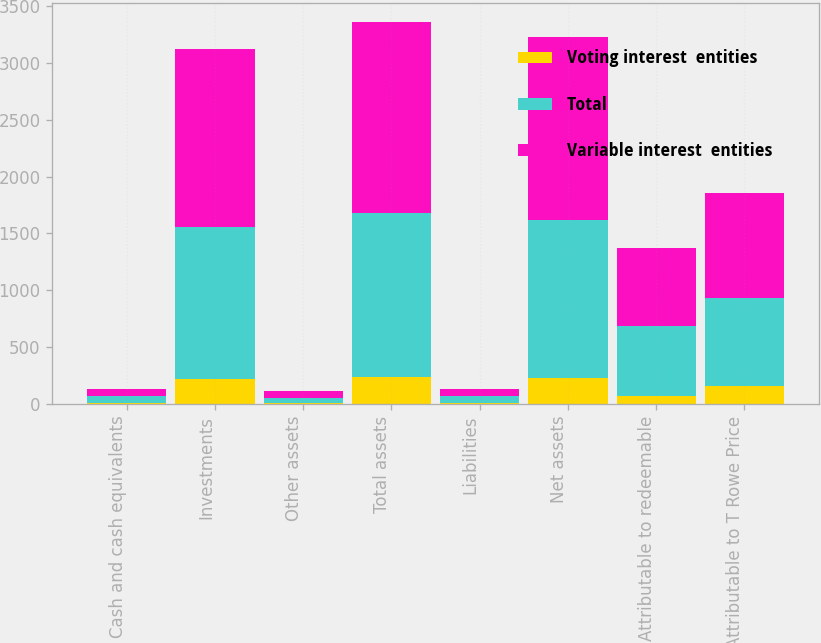Convert chart to OTSL. <chart><loc_0><loc_0><loc_500><loc_500><stacked_bar_chart><ecel><fcel>Cash and cash equivalents<fcel>Investments<fcel>Other assets<fcel>Total assets<fcel>Liabilities<fcel>Net assets<fcel>Attributable to redeemable<fcel>Attributable to T Rowe Price<nl><fcel>Voting interest  entities<fcel>10.3<fcel>219.3<fcel>4.8<fcel>234.4<fcel>8.8<fcel>225.6<fcel>69.5<fcel>156.1<nl><fcel>Total<fcel>55.3<fcel>1340.6<fcel>50.2<fcel>1446.1<fcel>56.8<fcel>1389.3<fcel>617.7<fcel>771.6<nl><fcel>Variable interest  entities<fcel>65.6<fcel>1559.9<fcel>55<fcel>1680.5<fcel>65.6<fcel>1614.9<fcel>687.2<fcel>927.7<nl></chart> 